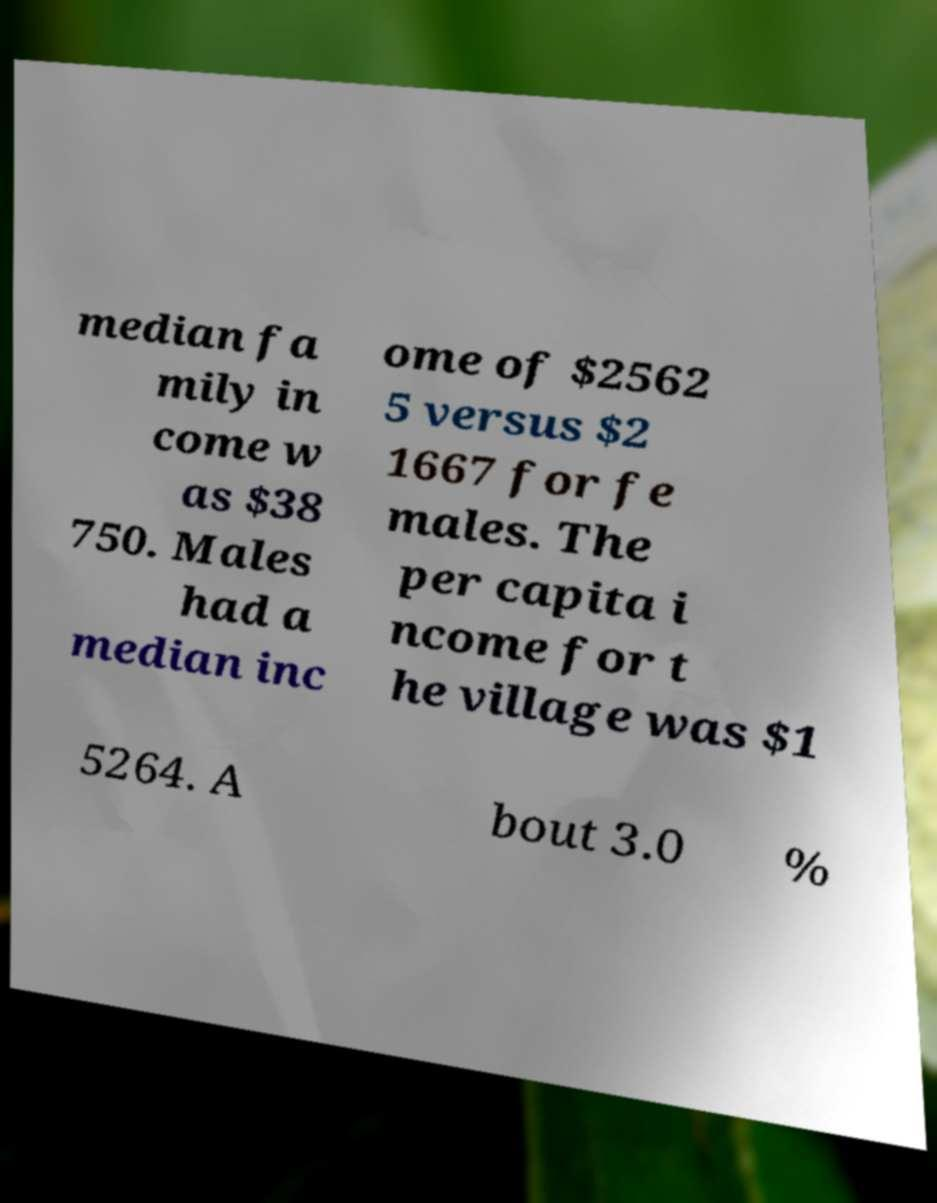For documentation purposes, I need the text within this image transcribed. Could you provide that? median fa mily in come w as $38 750. Males had a median inc ome of $2562 5 versus $2 1667 for fe males. The per capita i ncome for t he village was $1 5264. A bout 3.0 % 